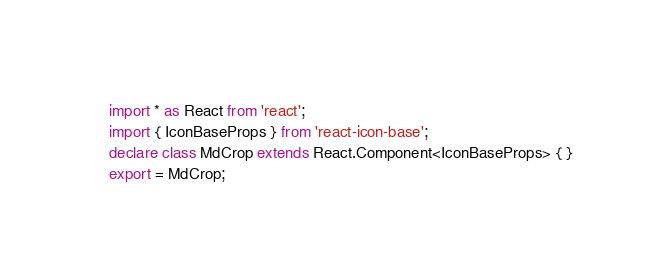Convert code to text. <code><loc_0><loc_0><loc_500><loc_500><_TypeScript_>import * as React from 'react';
import { IconBaseProps } from 'react-icon-base';
declare class MdCrop extends React.Component<IconBaseProps> { }
export = MdCrop;
</code> 